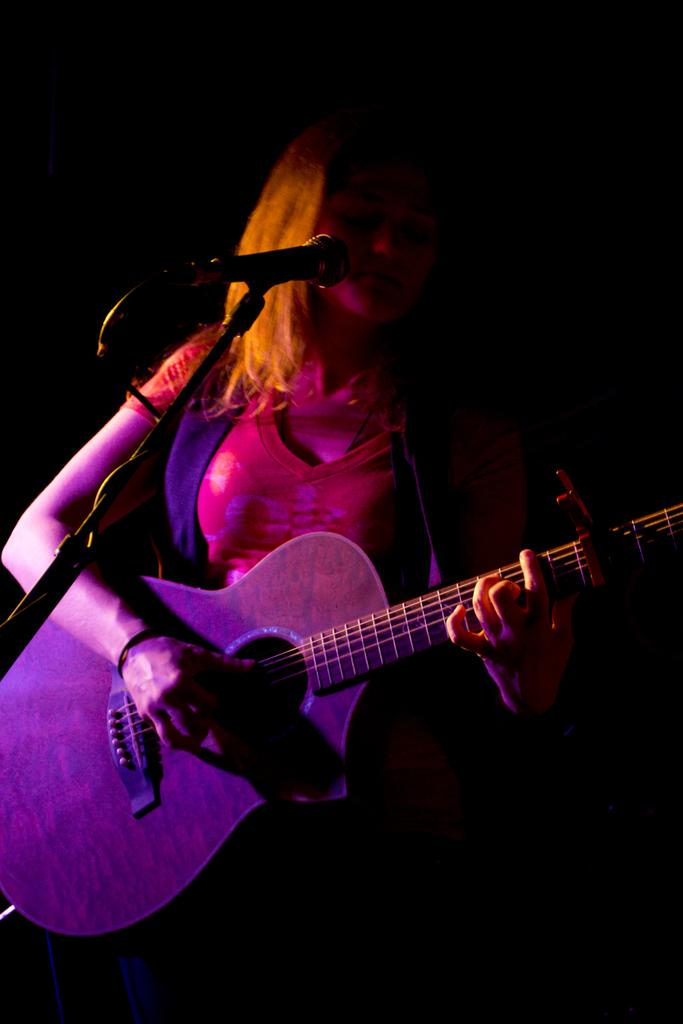Who is the main subject in the image? There is a woman in the image. What is the woman doing in the image? The woman is playing the guitar. Can you describe the woman's attire in the image? The woman is wearing a beautiful dress. What other object can be seen in the image? There is a microphone in the left side of the image. How many grapes are on the woman's dress in the image? There are no grapes visible on the woman's dress in the image. What type of loaf is being used as a prop in the image? There is no loaf present in the image. 